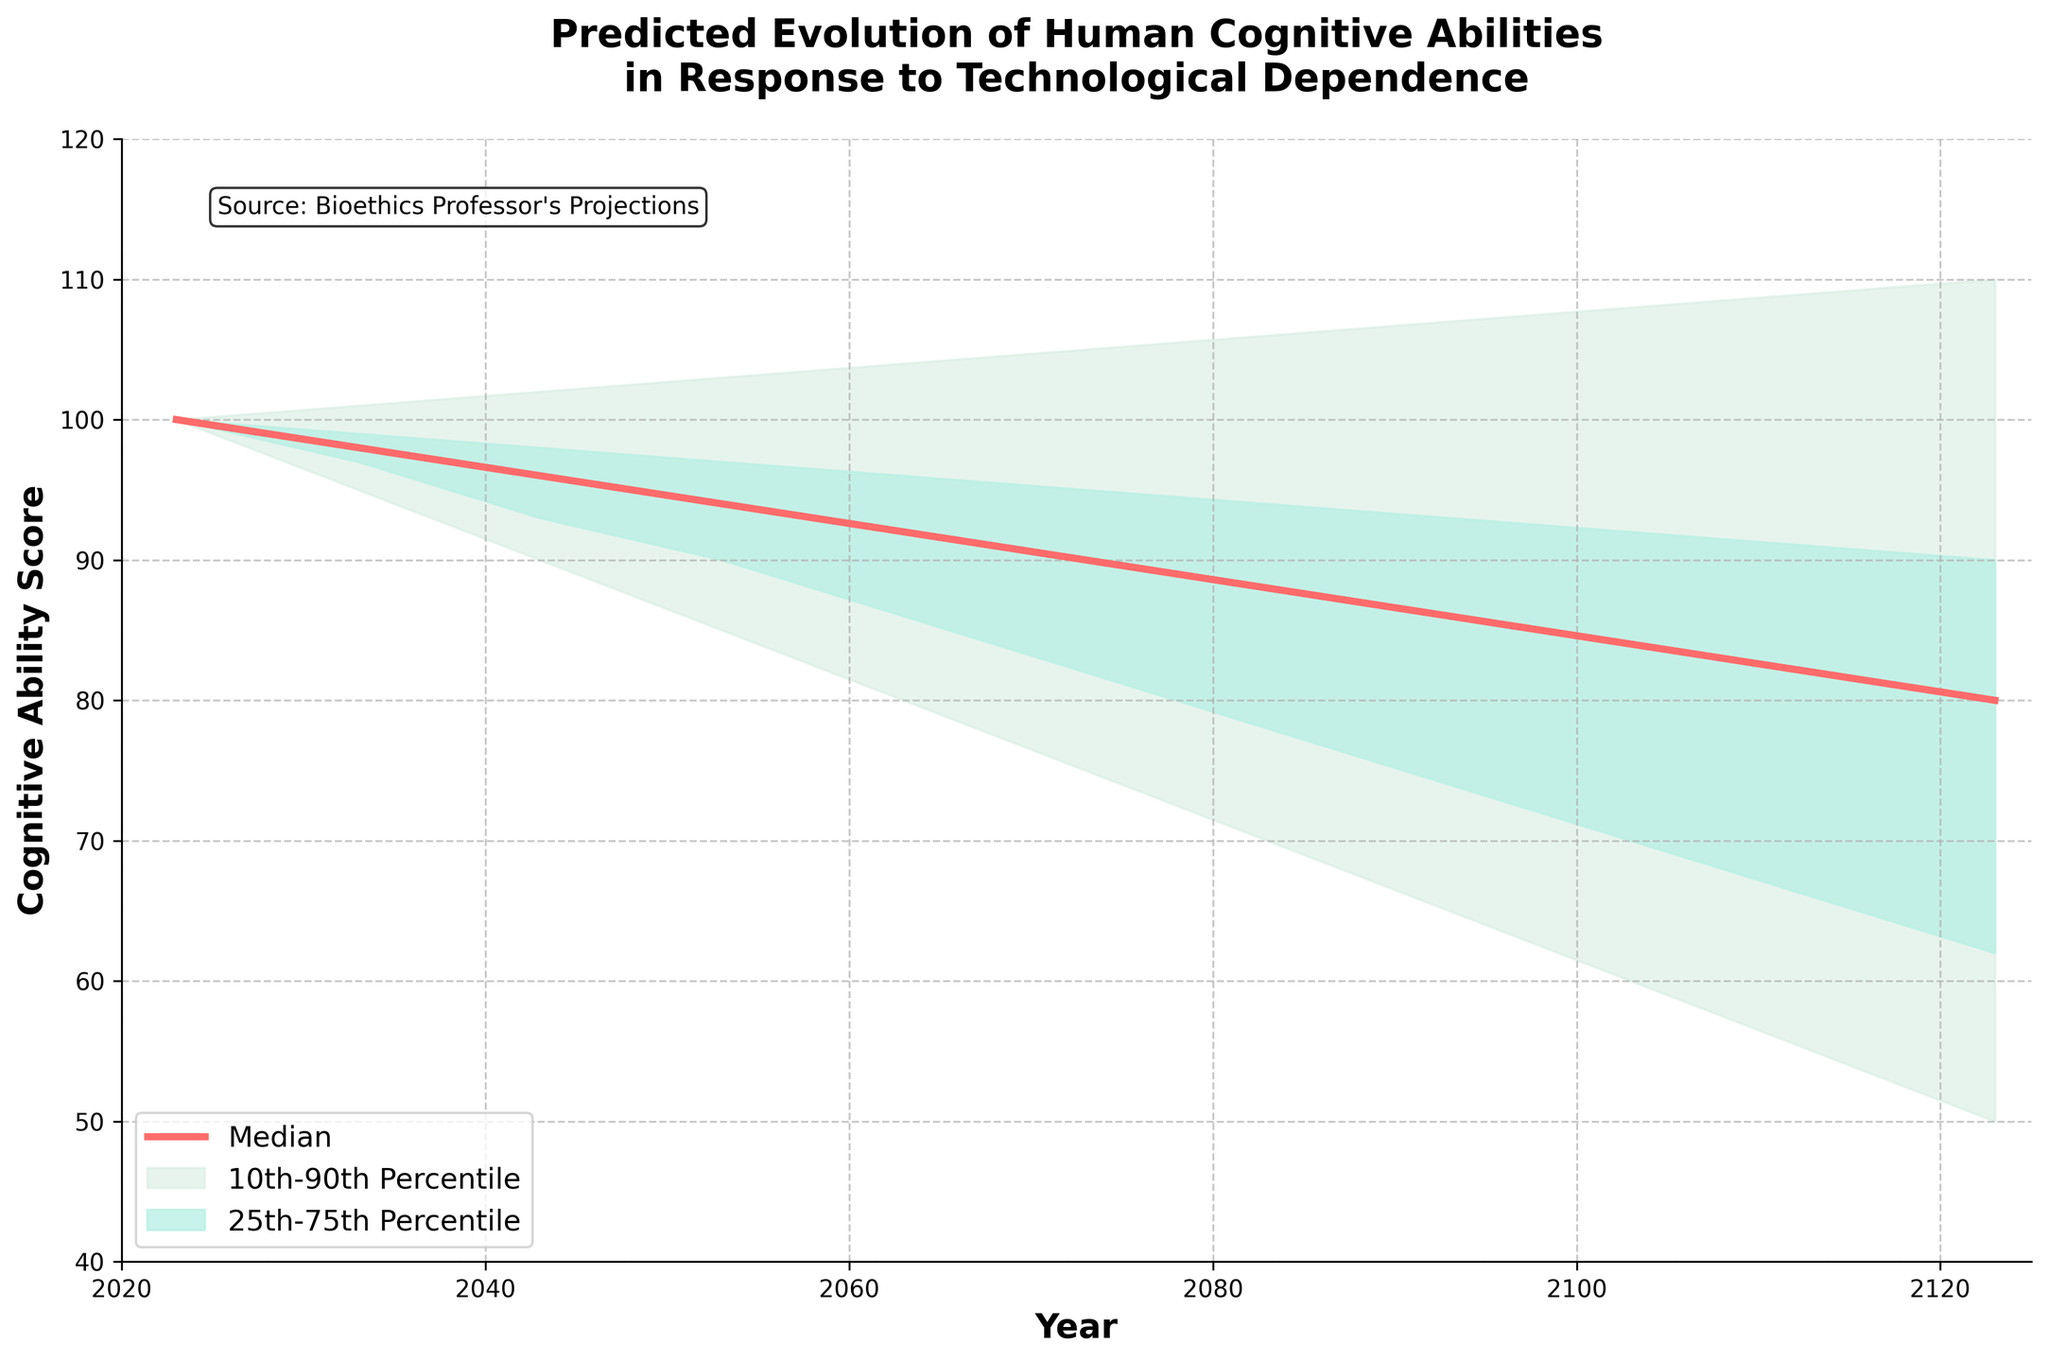what is the title of the chart? The title is usually found at the top of the chart and it provides a description of what the chart represents. Here, the title is "Predicted Evolution of Human Cognitive Abilities in Response to Technological Dependence".
Answer: Predicted Evolution of Human Cognitive Abilities in Response to Technological Dependence Which years act as the range for the prediction? The x-axis represents the range of years. By looking at the first and the last tick marks on the x-axis, we can see that the prediction ranges from 2023 to 2123.
Answer: 2023 to 2123 What is the median cognitive ability score in 2033? The median line is the bold line plotted through the middle of the chart. We trace this line to the year 2033 on the x-axis to find the median score value there which is 98.
Answer: 98 Which percentile range shows the most variation in cognitive ability scores over time? The two shaded areas on the plot represent the 10th-90th and 25th-75th percentile ranges. The 10th-90th percentile range (lighter shaded area) is wider, showing a greater variation over time.
Answer: 10th-90th percentile Compared to the median, which percentile shows the highest predicted cognitive ability score in 2123? To find the highest predicted score, we look at the 90th percentile value in the year 2123 on the y-axis. This is higher than both the median and the other percentiles.
Answer: 90th percentile What is the trend in the median cognitive ability score from 2023 to 2123? To determine the trend, we compare the starting (100 in 2023) and ending (80 in 2123) median values. The median cognitive ability score shows a decreasing trend.
Answer: Decreasing What are the cognitive ability score ranges between the 10th and 90th percentiles for the year 2083? From the chart, the y-values for the 10th and 90th percentiles in 2083 are 70 and 106 respectively. The difference between them gives the range.
Answer: 70 to 106 How do the 25th and 75th percentiles compare in the year 2063? We locate the y-values for the 25th (86) and 75th (96) percentiles for 2063. The difference between these values is 10 units, indicating the 75th is higher than the 25th by 10 cognitive points.
Answer: 75th percentile is 10 points higher In 2073, is the median cognitive ability score closer to the 25th percentile or the 75th percentile? For 2073, the median score is 90, the 25th percentile is at 82, and the 75th percentile is at 95. The median is 8 points away from the 25th percentile and 5 points away from the 75th percentile. Hence, it is closer to the 75th percentile.
Answer: 75th percentile What does the shaded area represent in the context of this fan chart? The shaded areas between the percentiles represent the range within which the predictions are likely to fall. Specifically, the darker shade shows the 25th-75th percentile, and the lighter shade shows the 10th-90th percentile.
Answer: Prediction ranges between percentiles 